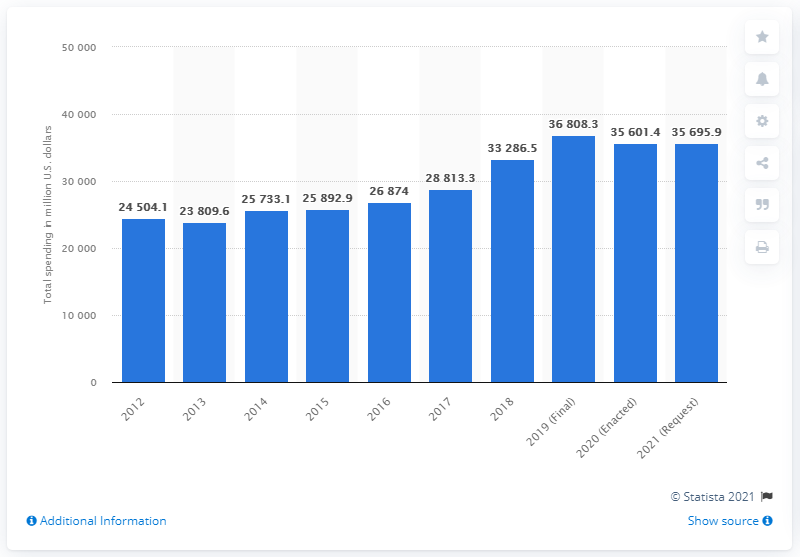Point out several critical features in this image. Federal drug control spending for the fiscal year 2019 was reported to be 36,808.3. The total federal drug control spending in the United States from Fiscal Year 2012 to Fiscal Year 2021 was 36,808.3 million dollars. 